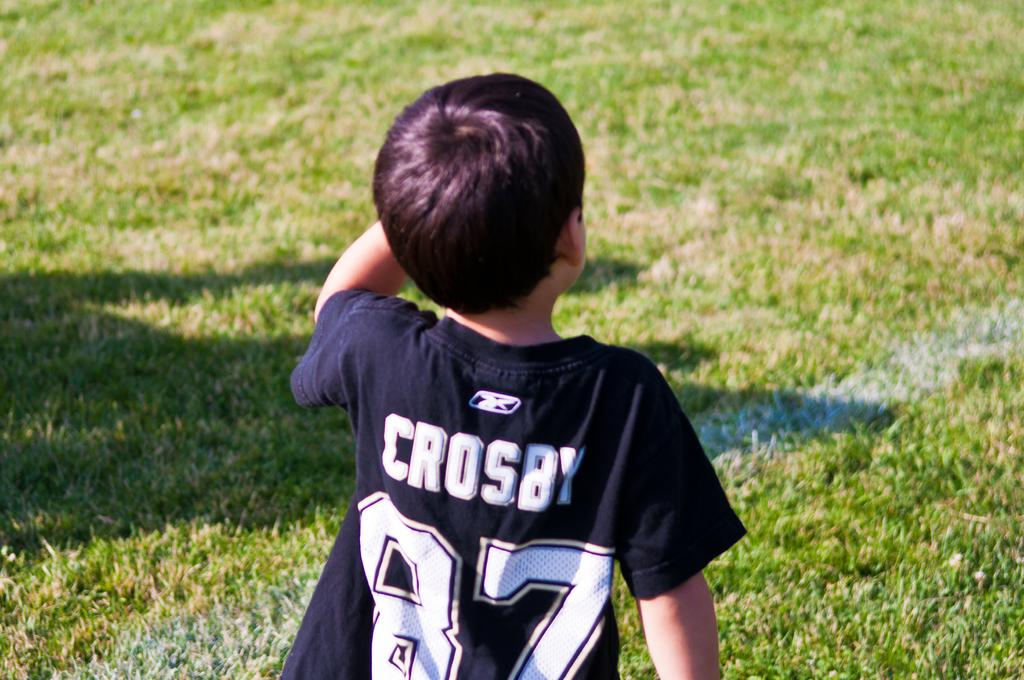<image>
Provide a brief description of the given image. A small boy is on a sports field wearing a number 87 CROSBY jersey. 